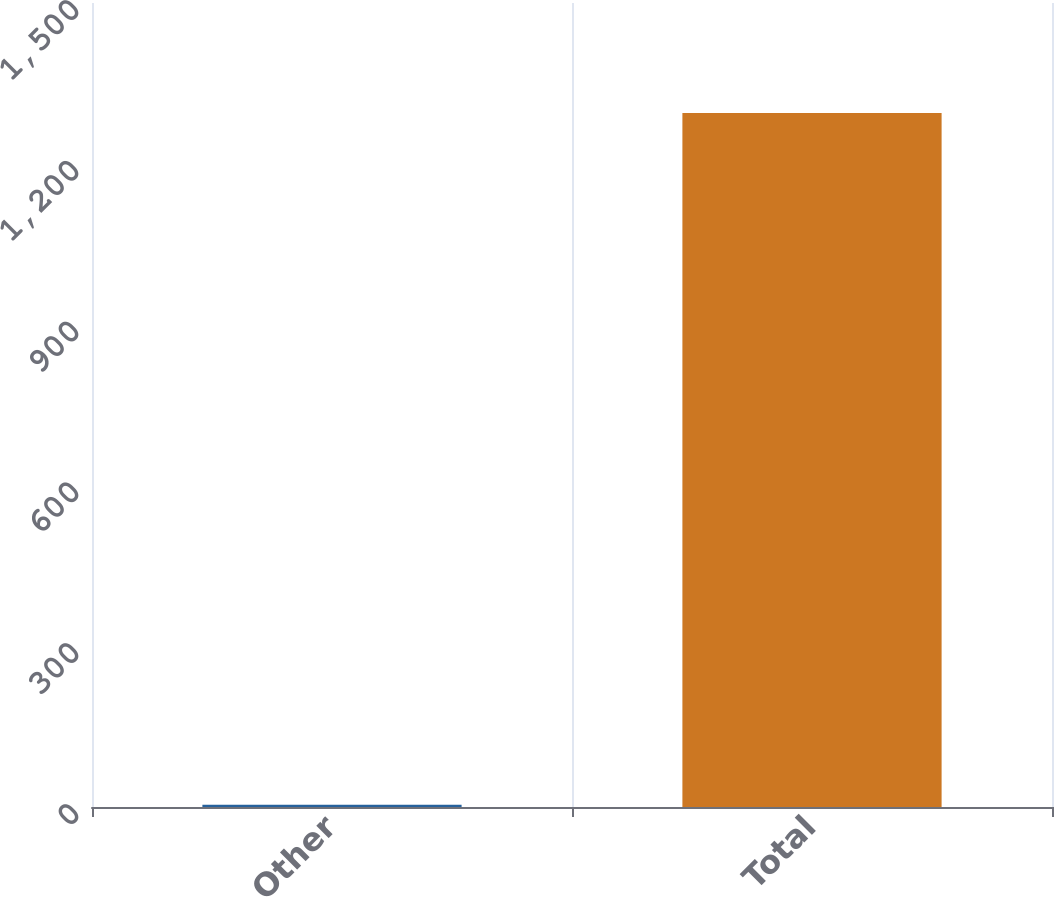Convert chart to OTSL. <chart><loc_0><loc_0><loc_500><loc_500><bar_chart><fcel>Other<fcel>Total<nl><fcel>4<fcel>1295<nl></chart> 